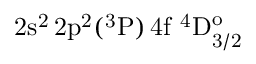<formula> <loc_0><loc_0><loc_500><loc_500>2 s ^ { 2 } \, 2 p ^ { 2 } ( ^ { 3 } P ) \, 4 f ^ { 4 } D _ { 3 / 2 } ^ { o }</formula> 